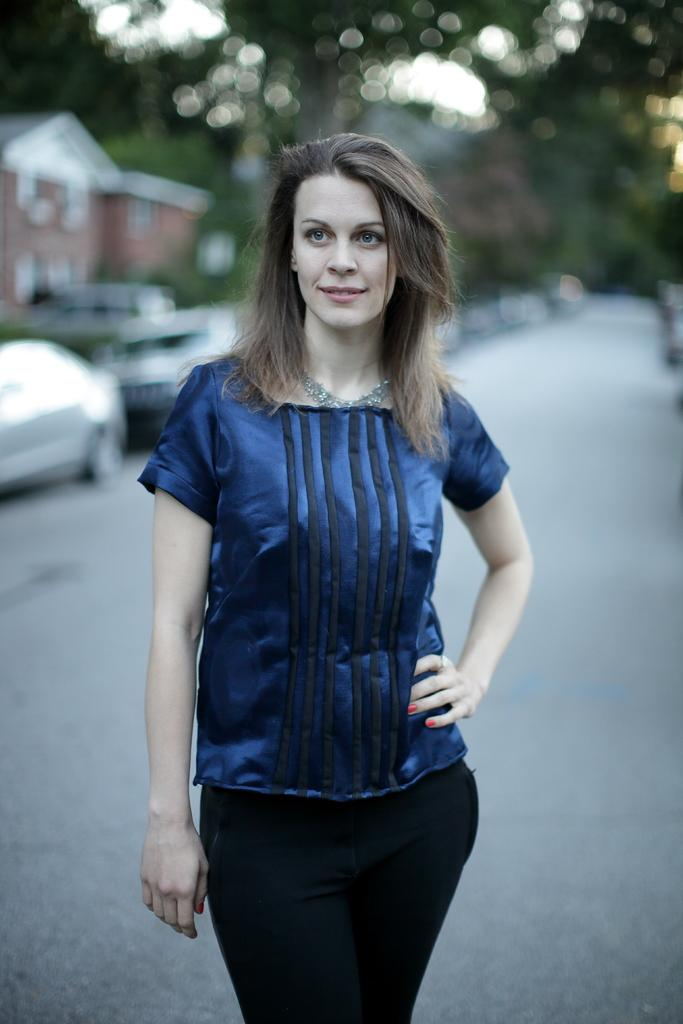What is the woman in the image doing? The woman is standing on the road. What can be seen in the background of the image? There are trees, vehicles, buildings, and the sky visible in the background of the image. What type of zinc is present in the image? There is no zinc present in the image. Where can the woman be seen eating her lunch in the image? The image does not show the woman eating lunch, nor is there a lunchroom depicted. 